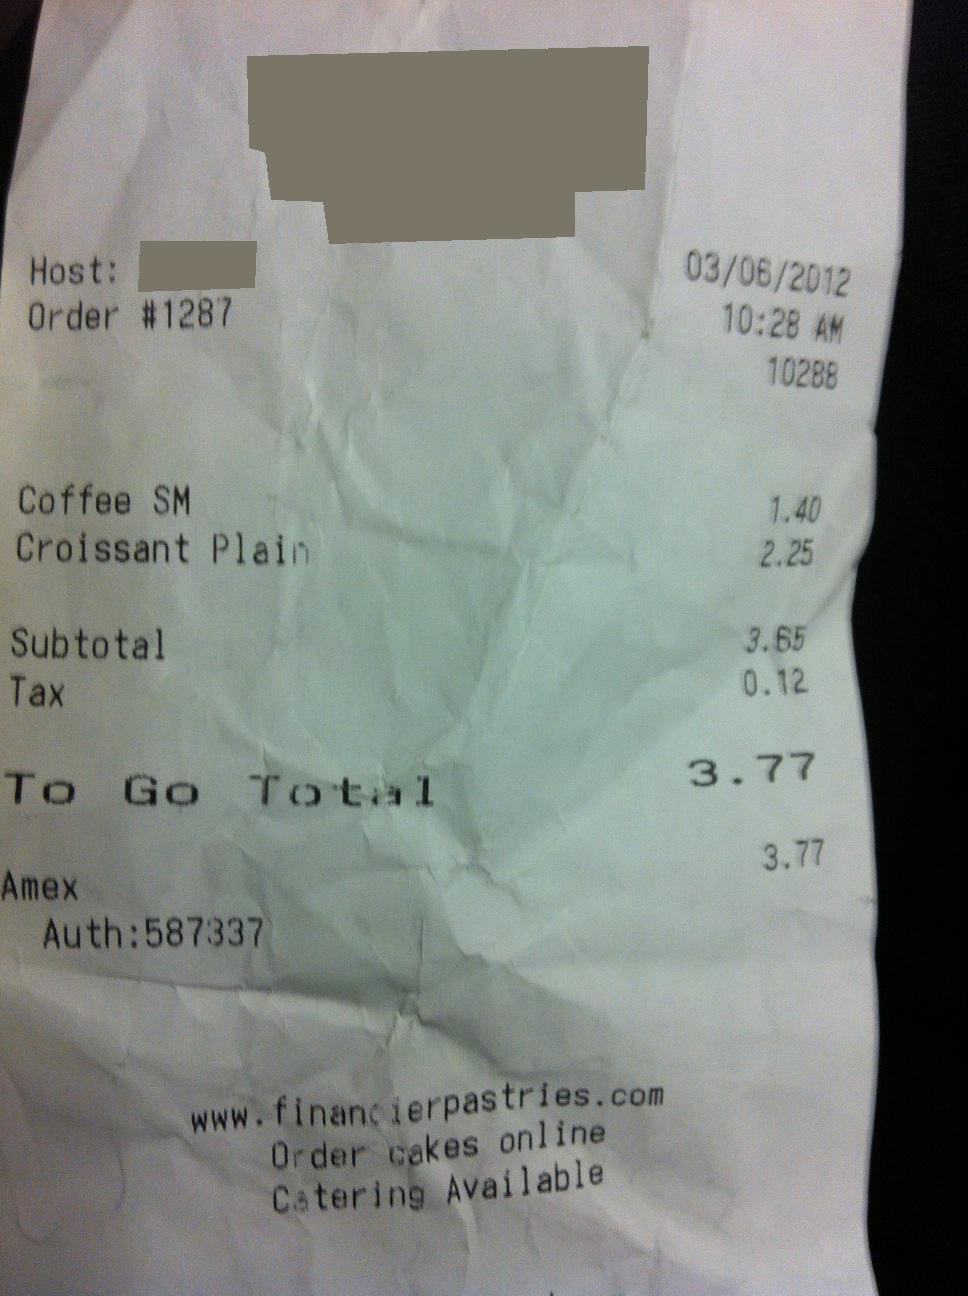What items were purchased according to this receipt? The receipt lists two items purchased: Coffee SM for $1.40 and a Croissant Plain for $2.25. These are the items that make up the subtotal of the bill. 